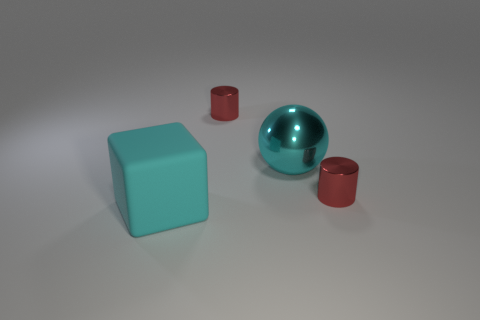Is there a red object behind the tiny red metallic cylinder that is to the left of the large sphere? no 